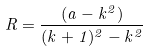<formula> <loc_0><loc_0><loc_500><loc_500>R = { \frac { ( a - k ^ { 2 } ) } { ( k + 1 ) ^ { 2 } - k ^ { 2 } } }</formula> 